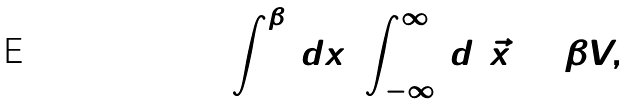Convert formula to latex. <formula><loc_0><loc_0><loc_500><loc_500>\int ^ { \beta } _ { 0 } \, d x _ { 4 } \int _ { - \infty } ^ { \infty } \, d ^ { 3 } { \vec { x } } = \beta V ,</formula> 